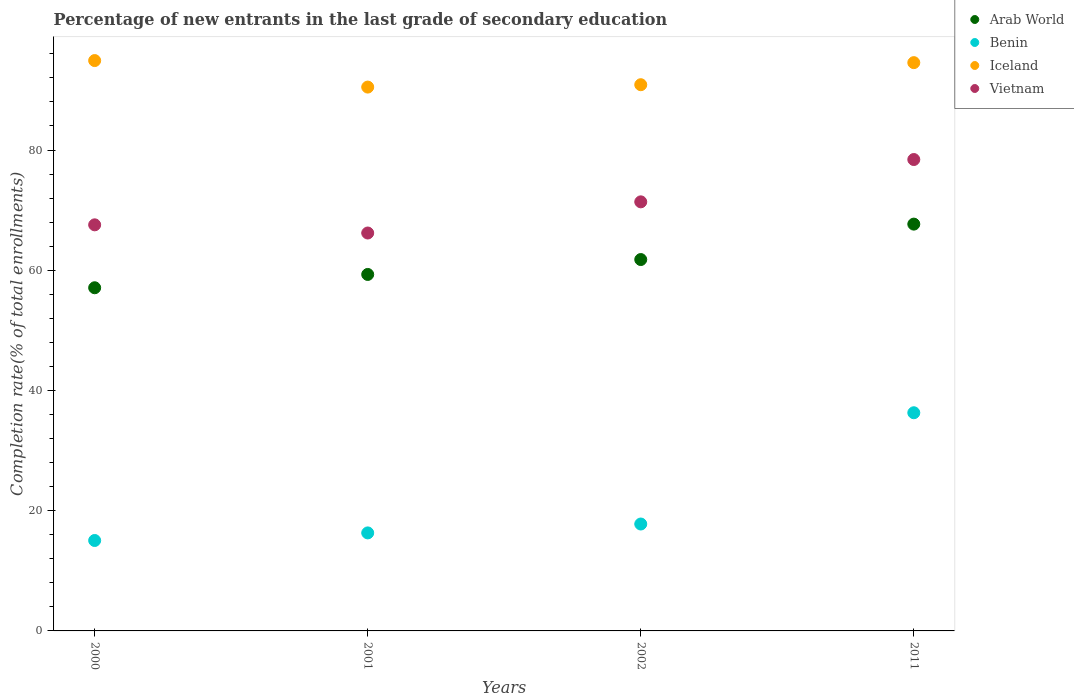How many different coloured dotlines are there?
Your answer should be compact. 4. Is the number of dotlines equal to the number of legend labels?
Offer a very short reply. Yes. What is the percentage of new entrants in Arab World in 2000?
Offer a very short reply. 57.09. Across all years, what is the maximum percentage of new entrants in Arab World?
Provide a short and direct response. 67.67. Across all years, what is the minimum percentage of new entrants in Vietnam?
Provide a short and direct response. 66.19. In which year was the percentage of new entrants in Iceland maximum?
Your answer should be compact. 2000. In which year was the percentage of new entrants in Arab World minimum?
Offer a very short reply. 2000. What is the total percentage of new entrants in Arab World in the graph?
Offer a terse response. 245.84. What is the difference between the percentage of new entrants in Vietnam in 2001 and that in 2002?
Ensure brevity in your answer.  -5.18. What is the difference between the percentage of new entrants in Vietnam in 2011 and the percentage of new entrants in Benin in 2001?
Your answer should be compact. 62.11. What is the average percentage of new entrants in Vietnam per year?
Offer a terse response. 70.89. In the year 2002, what is the difference between the percentage of new entrants in Iceland and percentage of new entrants in Arab World?
Offer a very short reply. 29.08. What is the ratio of the percentage of new entrants in Benin in 2002 to that in 2011?
Ensure brevity in your answer.  0.49. Is the percentage of new entrants in Benin in 2000 less than that in 2001?
Offer a terse response. Yes. What is the difference between the highest and the second highest percentage of new entrants in Arab World?
Keep it short and to the point. 5.89. What is the difference between the highest and the lowest percentage of new entrants in Vietnam?
Your answer should be very brief. 12.22. Is the sum of the percentage of new entrants in Iceland in 2000 and 2002 greater than the maximum percentage of new entrants in Vietnam across all years?
Provide a succinct answer. Yes. Is it the case that in every year, the sum of the percentage of new entrants in Iceland and percentage of new entrants in Vietnam  is greater than the sum of percentage of new entrants in Arab World and percentage of new entrants in Benin?
Your response must be concise. Yes. Does the percentage of new entrants in Iceland monotonically increase over the years?
Your response must be concise. No. Is the percentage of new entrants in Iceland strictly greater than the percentage of new entrants in Vietnam over the years?
Your response must be concise. Yes. How many dotlines are there?
Provide a succinct answer. 4. How many years are there in the graph?
Keep it short and to the point. 4. Does the graph contain any zero values?
Provide a succinct answer. No. Does the graph contain grids?
Provide a succinct answer. No. Where does the legend appear in the graph?
Provide a short and direct response. Top right. What is the title of the graph?
Give a very brief answer. Percentage of new entrants in the last grade of secondary education. What is the label or title of the X-axis?
Provide a succinct answer. Years. What is the label or title of the Y-axis?
Make the answer very short. Completion rate(% of total enrollments). What is the Completion rate(% of total enrollments) in Arab World in 2000?
Provide a short and direct response. 57.09. What is the Completion rate(% of total enrollments) of Benin in 2000?
Provide a short and direct response. 15.04. What is the Completion rate(% of total enrollments) in Iceland in 2000?
Offer a very short reply. 94.88. What is the Completion rate(% of total enrollments) of Vietnam in 2000?
Your answer should be very brief. 67.55. What is the Completion rate(% of total enrollments) in Arab World in 2001?
Provide a succinct answer. 59.3. What is the Completion rate(% of total enrollments) of Benin in 2001?
Your answer should be compact. 16.31. What is the Completion rate(% of total enrollments) of Iceland in 2001?
Give a very brief answer. 90.47. What is the Completion rate(% of total enrollments) of Vietnam in 2001?
Your response must be concise. 66.19. What is the Completion rate(% of total enrollments) of Arab World in 2002?
Give a very brief answer. 61.78. What is the Completion rate(% of total enrollments) in Benin in 2002?
Give a very brief answer. 17.78. What is the Completion rate(% of total enrollments) in Iceland in 2002?
Give a very brief answer. 90.86. What is the Completion rate(% of total enrollments) in Vietnam in 2002?
Make the answer very short. 71.38. What is the Completion rate(% of total enrollments) in Arab World in 2011?
Provide a succinct answer. 67.67. What is the Completion rate(% of total enrollments) of Benin in 2011?
Your answer should be very brief. 36.29. What is the Completion rate(% of total enrollments) in Iceland in 2011?
Your answer should be very brief. 94.54. What is the Completion rate(% of total enrollments) of Vietnam in 2011?
Offer a terse response. 78.42. Across all years, what is the maximum Completion rate(% of total enrollments) of Arab World?
Keep it short and to the point. 67.67. Across all years, what is the maximum Completion rate(% of total enrollments) of Benin?
Make the answer very short. 36.29. Across all years, what is the maximum Completion rate(% of total enrollments) in Iceland?
Make the answer very short. 94.88. Across all years, what is the maximum Completion rate(% of total enrollments) in Vietnam?
Your answer should be very brief. 78.42. Across all years, what is the minimum Completion rate(% of total enrollments) in Arab World?
Provide a short and direct response. 57.09. Across all years, what is the minimum Completion rate(% of total enrollments) of Benin?
Provide a succinct answer. 15.04. Across all years, what is the minimum Completion rate(% of total enrollments) in Iceland?
Provide a short and direct response. 90.47. Across all years, what is the minimum Completion rate(% of total enrollments) of Vietnam?
Offer a terse response. 66.19. What is the total Completion rate(% of total enrollments) of Arab World in the graph?
Offer a very short reply. 245.84. What is the total Completion rate(% of total enrollments) in Benin in the graph?
Your answer should be compact. 85.43. What is the total Completion rate(% of total enrollments) of Iceland in the graph?
Keep it short and to the point. 370.75. What is the total Completion rate(% of total enrollments) of Vietnam in the graph?
Your answer should be compact. 283.55. What is the difference between the Completion rate(% of total enrollments) in Arab World in 2000 and that in 2001?
Your response must be concise. -2.21. What is the difference between the Completion rate(% of total enrollments) in Benin in 2000 and that in 2001?
Provide a short and direct response. -1.26. What is the difference between the Completion rate(% of total enrollments) in Iceland in 2000 and that in 2001?
Provide a succinct answer. 4.41. What is the difference between the Completion rate(% of total enrollments) in Vietnam in 2000 and that in 2001?
Ensure brevity in your answer.  1.36. What is the difference between the Completion rate(% of total enrollments) in Arab World in 2000 and that in 2002?
Offer a terse response. -4.69. What is the difference between the Completion rate(% of total enrollments) in Benin in 2000 and that in 2002?
Offer a very short reply. -2.74. What is the difference between the Completion rate(% of total enrollments) of Iceland in 2000 and that in 2002?
Your answer should be compact. 4.02. What is the difference between the Completion rate(% of total enrollments) of Vietnam in 2000 and that in 2002?
Provide a succinct answer. -3.82. What is the difference between the Completion rate(% of total enrollments) of Arab World in 2000 and that in 2011?
Offer a terse response. -10.59. What is the difference between the Completion rate(% of total enrollments) of Benin in 2000 and that in 2011?
Your answer should be very brief. -21.25. What is the difference between the Completion rate(% of total enrollments) in Iceland in 2000 and that in 2011?
Keep it short and to the point. 0.34. What is the difference between the Completion rate(% of total enrollments) of Vietnam in 2000 and that in 2011?
Provide a succinct answer. -10.86. What is the difference between the Completion rate(% of total enrollments) of Arab World in 2001 and that in 2002?
Your response must be concise. -2.48. What is the difference between the Completion rate(% of total enrollments) in Benin in 2001 and that in 2002?
Offer a very short reply. -1.48. What is the difference between the Completion rate(% of total enrollments) of Iceland in 2001 and that in 2002?
Your answer should be very brief. -0.39. What is the difference between the Completion rate(% of total enrollments) in Vietnam in 2001 and that in 2002?
Provide a succinct answer. -5.18. What is the difference between the Completion rate(% of total enrollments) in Arab World in 2001 and that in 2011?
Offer a very short reply. -8.37. What is the difference between the Completion rate(% of total enrollments) in Benin in 2001 and that in 2011?
Provide a succinct answer. -19.99. What is the difference between the Completion rate(% of total enrollments) in Iceland in 2001 and that in 2011?
Ensure brevity in your answer.  -4.07. What is the difference between the Completion rate(% of total enrollments) of Vietnam in 2001 and that in 2011?
Your answer should be very brief. -12.22. What is the difference between the Completion rate(% of total enrollments) in Arab World in 2002 and that in 2011?
Your answer should be very brief. -5.89. What is the difference between the Completion rate(% of total enrollments) in Benin in 2002 and that in 2011?
Your answer should be very brief. -18.51. What is the difference between the Completion rate(% of total enrollments) in Iceland in 2002 and that in 2011?
Keep it short and to the point. -3.67. What is the difference between the Completion rate(% of total enrollments) in Vietnam in 2002 and that in 2011?
Your answer should be very brief. -7.04. What is the difference between the Completion rate(% of total enrollments) in Arab World in 2000 and the Completion rate(% of total enrollments) in Benin in 2001?
Keep it short and to the point. 40.78. What is the difference between the Completion rate(% of total enrollments) of Arab World in 2000 and the Completion rate(% of total enrollments) of Iceland in 2001?
Give a very brief answer. -33.38. What is the difference between the Completion rate(% of total enrollments) of Arab World in 2000 and the Completion rate(% of total enrollments) of Vietnam in 2001?
Provide a short and direct response. -9.11. What is the difference between the Completion rate(% of total enrollments) in Benin in 2000 and the Completion rate(% of total enrollments) in Iceland in 2001?
Make the answer very short. -75.43. What is the difference between the Completion rate(% of total enrollments) of Benin in 2000 and the Completion rate(% of total enrollments) of Vietnam in 2001?
Your response must be concise. -51.15. What is the difference between the Completion rate(% of total enrollments) in Iceland in 2000 and the Completion rate(% of total enrollments) in Vietnam in 2001?
Make the answer very short. 28.69. What is the difference between the Completion rate(% of total enrollments) in Arab World in 2000 and the Completion rate(% of total enrollments) in Benin in 2002?
Provide a succinct answer. 39.3. What is the difference between the Completion rate(% of total enrollments) of Arab World in 2000 and the Completion rate(% of total enrollments) of Iceland in 2002?
Keep it short and to the point. -33.78. What is the difference between the Completion rate(% of total enrollments) in Arab World in 2000 and the Completion rate(% of total enrollments) in Vietnam in 2002?
Ensure brevity in your answer.  -14.29. What is the difference between the Completion rate(% of total enrollments) in Benin in 2000 and the Completion rate(% of total enrollments) in Iceland in 2002?
Keep it short and to the point. -75.82. What is the difference between the Completion rate(% of total enrollments) in Benin in 2000 and the Completion rate(% of total enrollments) in Vietnam in 2002?
Your response must be concise. -56.34. What is the difference between the Completion rate(% of total enrollments) in Iceland in 2000 and the Completion rate(% of total enrollments) in Vietnam in 2002?
Make the answer very short. 23.5. What is the difference between the Completion rate(% of total enrollments) in Arab World in 2000 and the Completion rate(% of total enrollments) in Benin in 2011?
Provide a short and direct response. 20.79. What is the difference between the Completion rate(% of total enrollments) in Arab World in 2000 and the Completion rate(% of total enrollments) in Iceland in 2011?
Your response must be concise. -37.45. What is the difference between the Completion rate(% of total enrollments) of Arab World in 2000 and the Completion rate(% of total enrollments) of Vietnam in 2011?
Your response must be concise. -21.33. What is the difference between the Completion rate(% of total enrollments) in Benin in 2000 and the Completion rate(% of total enrollments) in Iceland in 2011?
Your answer should be very brief. -79.49. What is the difference between the Completion rate(% of total enrollments) in Benin in 2000 and the Completion rate(% of total enrollments) in Vietnam in 2011?
Offer a very short reply. -63.38. What is the difference between the Completion rate(% of total enrollments) in Iceland in 2000 and the Completion rate(% of total enrollments) in Vietnam in 2011?
Give a very brief answer. 16.46. What is the difference between the Completion rate(% of total enrollments) of Arab World in 2001 and the Completion rate(% of total enrollments) of Benin in 2002?
Your response must be concise. 41.52. What is the difference between the Completion rate(% of total enrollments) of Arab World in 2001 and the Completion rate(% of total enrollments) of Iceland in 2002?
Offer a very short reply. -31.56. What is the difference between the Completion rate(% of total enrollments) in Arab World in 2001 and the Completion rate(% of total enrollments) in Vietnam in 2002?
Offer a very short reply. -12.08. What is the difference between the Completion rate(% of total enrollments) in Benin in 2001 and the Completion rate(% of total enrollments) in Iceland in 2002?
Make the answer very short. -74.56. What is the difference between the Completion rate(% of total enrollments) of Benin in 2001 and the Completion rate(% of total enrollments) of Vietnam in 2002?
Your answer should be compact. -55.07. What is the difference between the Completion rate(% of total enrollments) of Iceland in 2001 and the Completion rate(% of total enrollments) of Vietnam in 2002?
Provide a short and direct response. 19.09. What is the difference between the Completion rate(% of total enrollments) in Arab World in 2001 and the Completion rate(% of total enrollments) in Benin in 2011?
Provide a short and direct response. 23.01. What is the difference between the Completion rate(% of total enrollments) of Arab World in 2001 and the Completion rate(% of total enrollments) of Iceland in 2011?
Provide a short and direct response. -35.23. What is the difference between the Completion rate(% of total enrollments) of Arab World in 2001 and the Completion rate(% of total enrollments) of Vietnam in 2011?
Offer a terse response. -19.12. What is the difference between the Completion rate(% of total enrollments) of Benin in 2001 and the Completion rate(% of total enrollments) of Iceland in 2011?
Provide a short and direct response. -78.23. What is the difference between the Completion rate(% of total enrollments) in Benin in 2001 and the Completion rate(% of total enrollments) in Vietnam in 2011?
Keep it short and to the point. -62.11. What is the difference between the Completion rate(% of total enrollments) of Iceland in 2001 and the Completion rate(% of total enrollments) of Vietnam in 2011?
Keep it short and to the point. 12.05. What is the difference between the Completion rate(% of total enrollments) in Arab World in 2002 and the Completion rate(% of total enrollments) in Benin in 2011?
Provide a succinct answer. 25.49. What is the difference between the Completion rate(% of total enrollments) in Arab World in 2002 and the Completion rate(% of total enrollments) in Iceland in 2011?
Provide a succinct answer. -32.76. What is the difference between the Completion rate(% of total enrollments) in Arab World in 2002 and the Completion rate(% of total enrollments) in Vietnam in 2011?
Ensure brevity in your answer.  -16.64. What is the difference between the Completion rate(% of total enrollments) in Benin in 2002 and the Completion rate(% of total enrollments) in Iceland in 2011?
Keep it short and to the point. -76.75. What is the difference between the Completion rate(% of total enrollments) of Benin in 2002 and the Completion rate(% of total enrollments) of Vietnam in 2011?
Your answer should be compact. -60.63. What is the difference between the Completion rate(% of total enrollments) in Iceland in 2002 and the Completion rate(% of total enrollments) in Vietnam in 2011?
Provide a succinct answer. 12.45. What is the average Completion rate(% of total enrollments) of Arab World per year?
Provide a short and direct response. 61.46. What is the average Completion rate(% of total enrollments) in Benin per year?
Keep it short and to the point. 21.36. What is the average Completion rate(% of total enrollments) of Iceland per year?
Provide a short and direct response. 92.69. What is the average Completion rate(% of total enrollments) in Vietnam per year?
Provide a succinct answer. 70.89. In the year 2000, what is the difference between the Completion rate(% of total enrollments) in Arab World and Completion rate(% of total enrollments) in Benin?
Your answer should be compact. 42.04. In the year 2000, what is the difference between the Completion rate(% of total enrollments) in Arab World and Completion rate(% of total enrollments) in Iceland?
Provide a short and direct response. -37.79. In the year 2000, what is the difference between the Completion rate(% of total enrollments) in Arab World and Completion rate(% of total enrollments) in Vietnam?
Offer a terse response. -10.47. In the year 2000, what is the difference between the Completion rate(% of total enrollments) of Benin and Completion rate(% of total enrollments) of Iceland?
Keep it short and to the point. -79.84. In the year 2000, what is the difference between the Completion rate(% of total enrollments) in Benin and Completion rate(% of total enrollments) in Vietnam?
Your answer should be very brief. -52.51. In the year 2000, what is the difference between the Completion rate(% of total enrollments) in Iceland and Completion rate(% of total enrollments) in Vietnam?
Keep it short and to the point. 27.33. In the year 2001, what is the difference between the Completion rate(% of total enrollments) in Arab World and Completion rate(% of total enrollments) in Benin?
Your answer should be compact. 43. In the year 2001, what is the difference between the Completion rate(% of total enrollments) of Arab World and Completion rate(% of total enrollments) of Iceland?
Your response must be concise. -31.17. In the year 2001, what is the difference between the Completion rate(% of total enrollments) in Arab World and Completion rate(% of total enrollments) in Vietnam?
Your answer should be very brief. -6.89. In the year 2001, what is the difference between the Completion rate(% of total enrollments) in Benin and Completion rate(% of total enrollments) in Iceland?
Make the answer very short. -74.17. In the year 2001, what is the difference between the Completion rate(% of total enrollments) in Benin and Completion rate(% of total enrollments) in Vietnam?
Keep it short and to the point. -49.89. In the year 2001, what is the difference between the Completion rate(% of total enrollments) of Iceland and Completion rate(% of total enrollments) of Vietnam?
Your answer should be very brief. 24.28. In the year 2002, what is the difference between the Completion rate(% of total enrollments) of Arab World and Completion rate(% of total enrollments) of Benin?
Provide a succinct answer. 44. In the year 2002, what is the difference between the Completion rate(% of total enrollments) in Arab World and Completion rate(% of total enrollments) in Iceland?
Keep it short and to the point. -29.08. In the year 2002, what is the difference between the Completion rate(% of total enrollments) in Arab World and Completion rate(% of total enrollments) in Vietnam?
Provide a succinct answer. -9.6. In the year 2002, what is the difference between the Completion rate(% of total enrollments) in Benin and Completion rate(% of total enrollments) in Iceland?
Your answer should be compact. -73.08. In the year 2002, what is the difference between the Completion rate(% of total enrollments) in Benin and Completion rate(% of total enrollments) in Vietnam?
Give a very brief answer. -53.6. In the year 2002, what is the difference between the Completion rate(% of total enrollments) in Iceland and Completion rate(% of total enrollments) in Vietnam?
Offer a very short reply. 19.49. In the year 2011, what is the difference between the Completion rate(% of total enrollments) in Arab World and Completion rate(% of total enrollments) in Benin?
Ensure brevity in your answer.  31.38. In the year 2011, what is the difference between the Completion rate(% of total enrollments) in Arab World and Completion rate(% of total enrollments) in Iceland?
Give a very brief answer. -26.86. In the year 2011, what is the difference between the Completion rate(% of total enrollments) in Arab World and Completion rate(% of total enrollments) in Vietnam?
Make the answer very short. -10.74. In the year 2011, what is the difference between the Completion rate(% of total enrollments) in Benin and Completion rate(% of total enrollments) in Iceland?
Offer a terse response. -58.24. In the year 2011, what is the difference between the Completion rate(% of total enrollments) in Benin and Completion rate(% of total enrollments) in Vietnam?
Ensure brevity in your answer.  -42.12. In the year 2011, what is the difference between the Completion rate(% of total enrollments) of Iceland and Completion rate(% of total enrollments) of Vietnam?
Offer a very short reply. 16.12. What is the ratio of the Completion rate(% of total enrollments) in Arab World in 2000 to that in 2001?
Ensure brevity in your answer.  0.96. What is the ratio of the Completion rate(% of total enrollments) of Benin in 2000 to that in 2001?
Provide a short and direct response. 0.92. What is the ratio of the Completion rate(% of total enrollments) of Iceland in 2000 to that in 2001?
Make the answer very short. 1.05. What is the ratio of the Completion rate(% of total enrollments) of Vietnam in 2000 to that in 2001?
Your response must be concise. 1.02. What is the ratio of the Completion rate(% of total enrollments) of Arab World in 2000 to that in 2002?
Keep it short and to the point. 0.92. What is the ratio of the Completion rate(% of total enrollments) in Benin in 2000 to that in 2002?
Make the answer very short. 0.85. What is the ratio of the Completion rate(% of total enrollments) of Iceland in 2000 to that in 2002?
Keep it short and to the point. 1.04. What is the ratio of the Completion rate(% of total enrollments) in Vietnam in 2000 to that in 2002?
Provide a short and direct response. 0.95. What is the ratio of the Completion rate(% of total enrollments) in Arab World in 2000 to that in 2011?
Provide a succinct answer. 0.84. What is the ratio of the Completion rate(% of total enrollments) in Benin in 2000 to that in 2011?
Ensure brevity in your answer.  0.41. What is the ratio of the Completion rate(% of total enrollments) in Vietnam in 2000 to that in 2011?
Offer a very short reply. 0.86. What is the ratio of the Completion rate(% of total enrollments) of Arab World in 2001 to that in 2002?
Provide a short and direct response. 0.96. What is the ratio of the Completion rate(% of total enrollments) in Benin in 2001 to that in 2002?
Ensure brevity in your answer.  0.92. What is the ratio of the Completion rate(% of total enrollments) in Iceland in 2001 to that in 2002?
Give a very brief answer. 1. What is the ratio of the Completion rate(% of total enrollments) of Vietnam in 2001 to that in 2002?
Offer a terse response. 0.93. What is the ratio of the Completion rate(% of total enrollments) of Arab World in 2001 to that in 2011?
Your answer should be very brief. 0.88. What is the ratio of the Completion rate(% of total enrollments) of Benin in 2001 to that in 2011?
Provide a short and direct response. 0.45. What is the ratio of the Completion rate(% of total enrollments) of Vietnam in 2001 to that in 2011?
Offer a very short reply. 0.84. What is the ratio of the Completion rate(% of total enrollments) in Arab World in 2002 to that in 2011?
Your answer should be very brief. 0.91. What is the ratio of the Completion rate(% of total enrollments) in Benin in 2002 to that in 2011?
Your answer should be very brief. 0.49. What is the ratio of the Completion rate(% of total enrollments) of Iceland in 2002 to that in 2011?
Keep it short and to the point. 0.96. What is the ratio of the Completion rate(% of total enrollments) in Vietnam in 2002 to that in 2011?
Provide a succinct answer. 0.91. What is the difference between the highest and the second highest Completion rate(% of total enrollments) in Arab World?
Offer a very short reply. 5.89. What is the difference between the highest and the second highest Completion rate(% of total enrollments) in Benin?
Provide a succinct answer. 18.51. What is the difference between the highest and the second highest Completion rate(% of total enrollments) of Iceland?
Your answer should be compact. 0.34. What is the difference between the highest and the second highest Completion rate(% of total enrollments) of Vietnam?
Offer a terse response. 7.04. What is the difference between the highest and the lowest Completion rate(% of total enrollments) of Arab World?
Give a very brief answer. 10.59. What is the difference between the highest and the lowest Completion rate(% of total enrollments) in Benin?
Provide a short and direct response. 21.25. What is the difference between the highest and the lowest Completion rate(% of total enrollments) of Iceland?
Ensure brevity in your answer.  4.41. What is the difference between the highest and the lowest Completion rate(% of total enrollments) in Vietnam?
Your answer should be very brief. 12.22. 